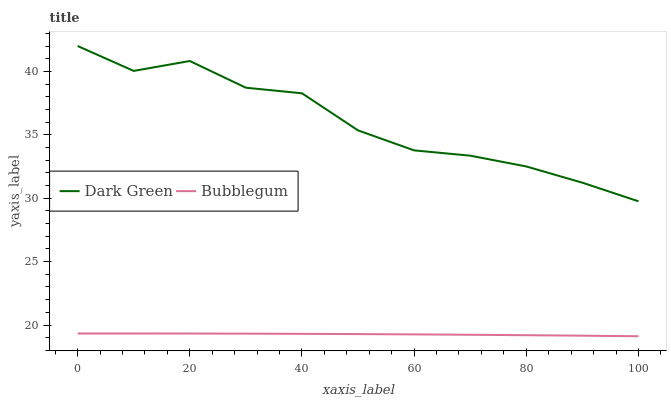Does Dark Green have the minimum area under the curve?
Answer yes or no. No. Is Dark Green the smoothest?
Answer yes or no. No. Does Dark Green have the lowest value?
Answer yes or no. No. Is Bubblegum less than Dark Green?
Answer yes or no. Yes. Is Dark Green greater than Bubblegum?
Answer yes or no. Yes. Does Bubblegum intersect Dark Green?
Answer yes or no. No. 